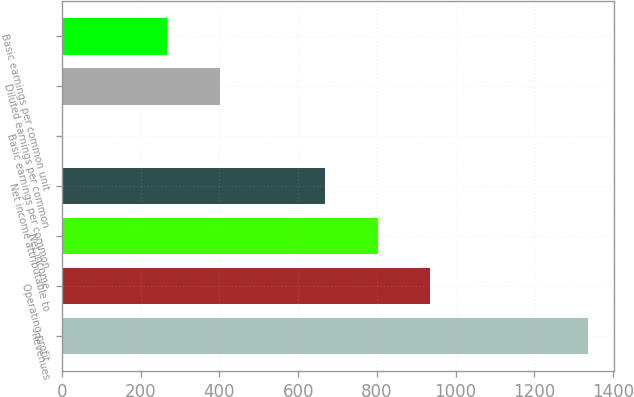<chart> <loc_0><loc_0><loc_500><loc_500><bar_chart><fcel>Revenues<fcel>Operating profit<fcel>Net income<fcel>Net income attributable to<fcel>Basic earnings per common<fcel>Diluted earnings per common<fcel>Basic earnings per common unit<nl><fcel>1337<fcel>935.93<fcel>802.25<fcel>668.57<fcel>0.17<fcel>401.21<fcel>267.53<nl></chart> 